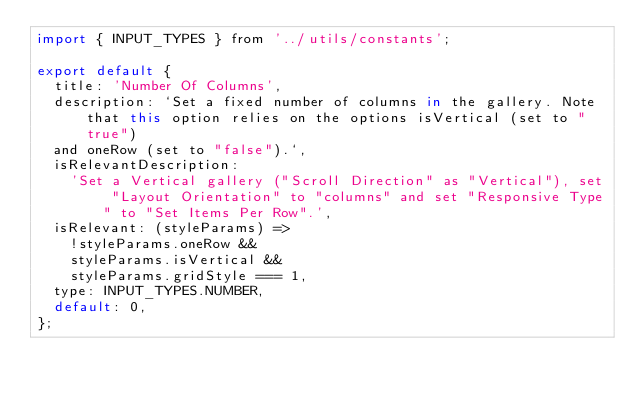<code> <loc_0><loc_0><loc_500><loc_500><_JavaScript_>import { INPUT_TYPES } from '../utils/constants';

export default {
  title: 'Number Of Columns',
  description: `Set a fixed number of columns in the gallery. Note that this option relies on the options isVertical (set to "true")
  and oneRow (set to "false").`,
  isRelevantDescription:
    'Set a Vertical gallery ("Scroll Direction" as "Vertical"), set "Layout Orientation" to "columns" and set "Responsive Type" to "Set Items Per Row".',
  isRelevant: (styleParams) =>
    !styleParams.oneRow &&
    styleParams.isVertical &&
    styleParams.gridStyle === 1,
  type: INPUT_TYPES.NUMBER,
  default: 0,
};
</code> 